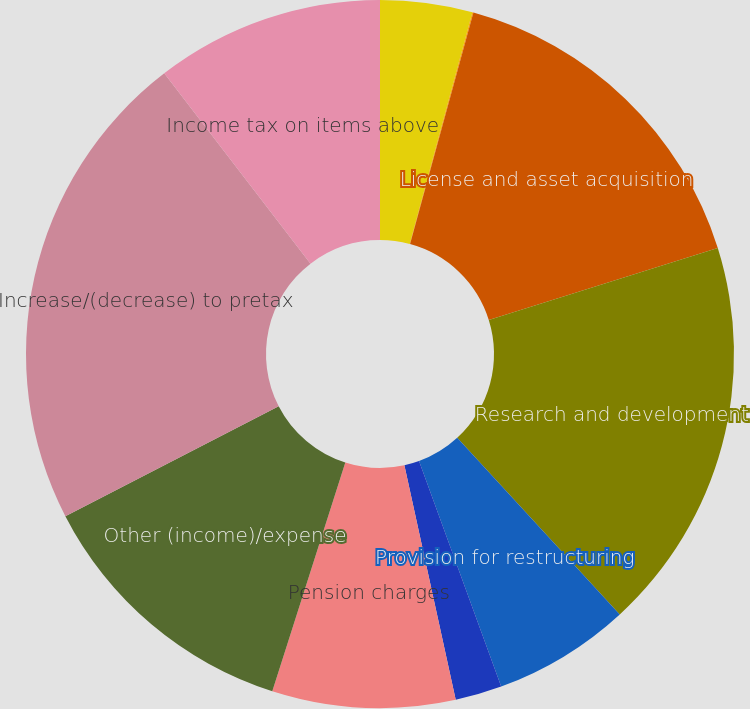Convert chart. <chart><loc_0><loc_0><loc_500><loc_500><pie_chart><fcel>Cost of products sold (a)<fcel>Marketing selling and<fcel>License and asset acquisition<fcel>Research and development<fcel>Provision for restructuring<fcel>Divestiture (gains)/losses<fcel>Pension charges<fcel>Other (income)/expense<fcel>Increase/(decrease) to pretax<fcel>Income tax on items above<nl><fcel>4.2%<fcel>0.05%<fcel>15.91%<fcel>17.99%<fcel>6.28%<fcel>2.13%<fcel>8.35%<fcel>12.5%<fcel>22.14%<fcel>10.43%<nl></chart> 